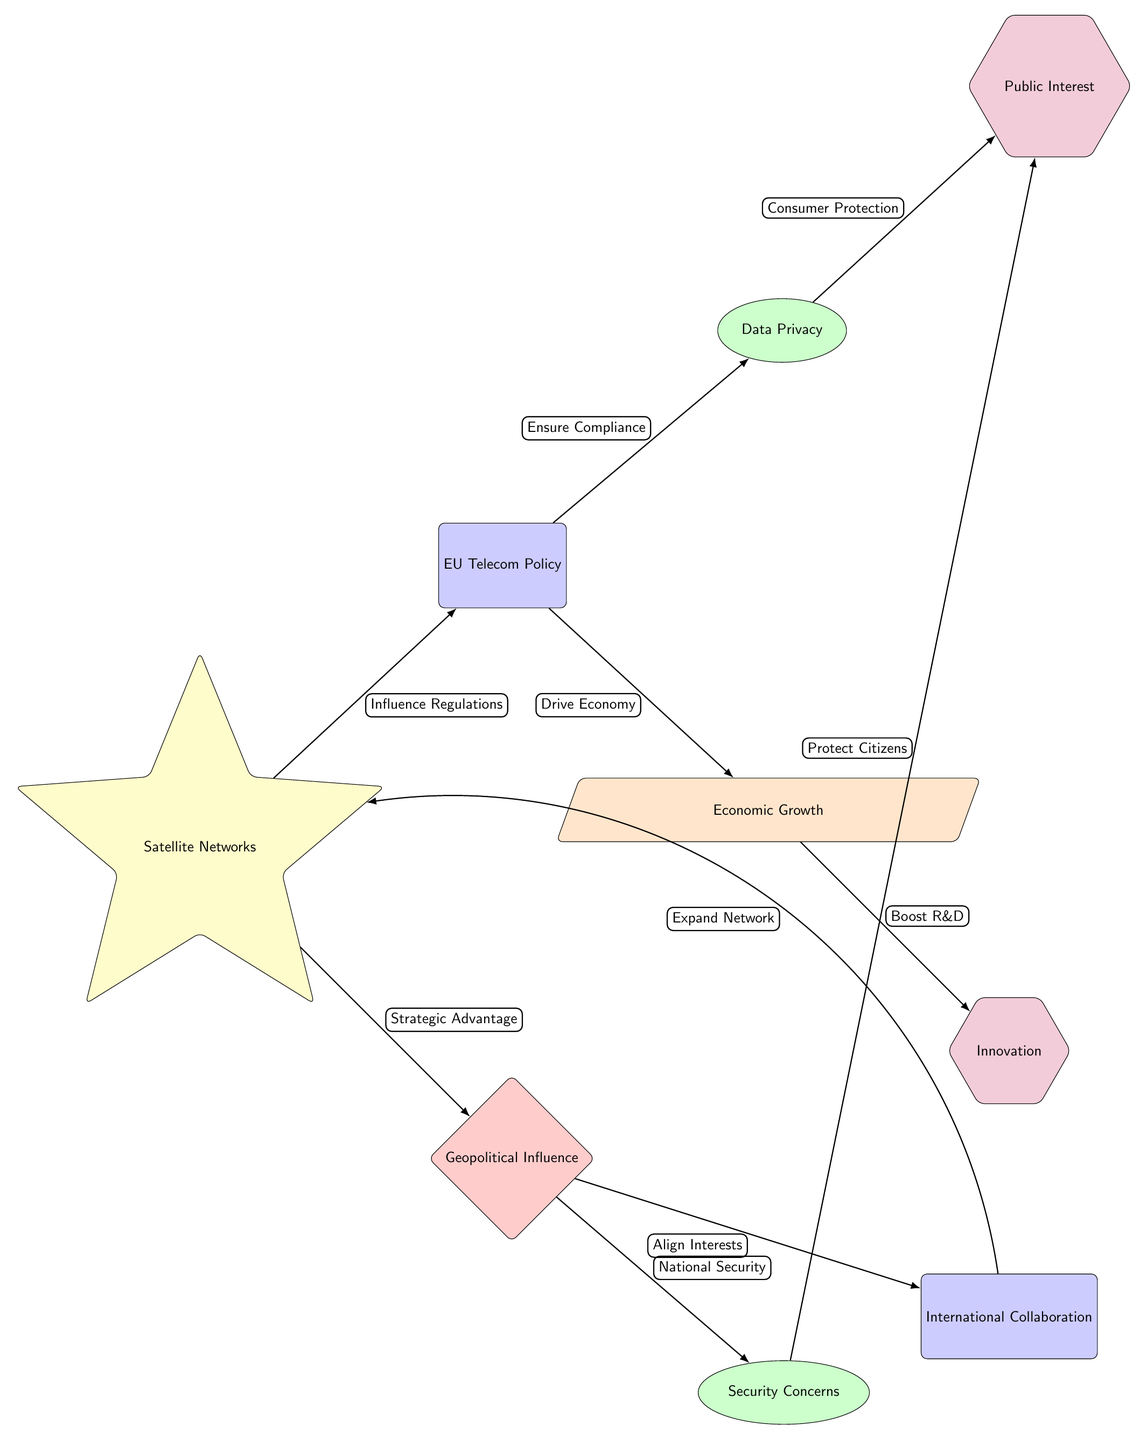What is the main subject of the diagram? The central theme of the diagram is represented by the node labeled "Satellite Networks," which indicates that the influence revolves around satellite distribution.
Answer: Satellite Networks How many nodes are present in the diagram? By counting all the distinct shapes in the diagram, there are a total of 8 nodes displayed.
Answer: 8 What type of influence does the "Satellite Networks" have on "EU Telecom Policy"? The arrow from "Satellite Networks" to "EU Telecom Policy" is labeled "Influence Regulations," indicating a regulatory impact.
Answer: Influence Regulations What relationship exists between "Geopolitical Influence" and "Security Concerns"? The connection is established through an edge pointing from "Geopolitical Influence" to "Security Concerns," indicating that geopolitical aspects influence security matters.
Answer: National Security Which policy aspect is related to "Data Privacy"? The diagram shows a path leading from "EU Telecom Policy" to "Data Privacy," demonstrating a connection focused on consumer protection and compliance.
Answer: Ensure Compliance How does "Economic Growth" interact with "Innovation"? "Economic Growth" gives rise to "Innovation," as depicted by the edge labeled "Boost R&D," emphasizing how economic factors can foster research and development.
Answer: Boost R&D What influences the "Public Interest"? The influence on "Public Interest" stems from both "Data Privacy" and "Security Concerns," showing how different concerns affect public perceptions and actions.
Answer: Consumer Protection How do "International Collaboration" and "Satellite Networks" connect? The connection is represented by an edge labeled "Expand Network," indicating that international efforts can lead to the expansion of satellite systems.
Answer: Expand Network What is the role of "Consumer Protection" in relation to "Public Interest"? "Consumer Protection" affects "Public Interest," as shown by the edge leading from "Data Privacy" to "Public Interest," indicating a direct influence in ensuring consumer rights.
Answer: Consumer Protection 